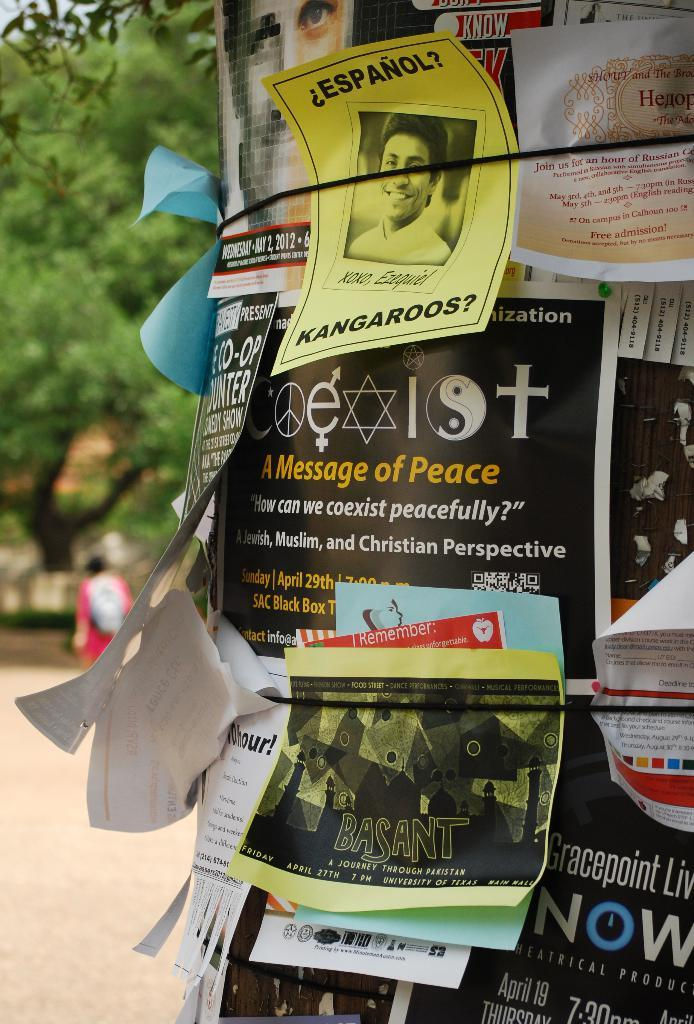<image>
Share a concise interpretation of the image provided. A sign on a telephone pole shares a message of peace. 